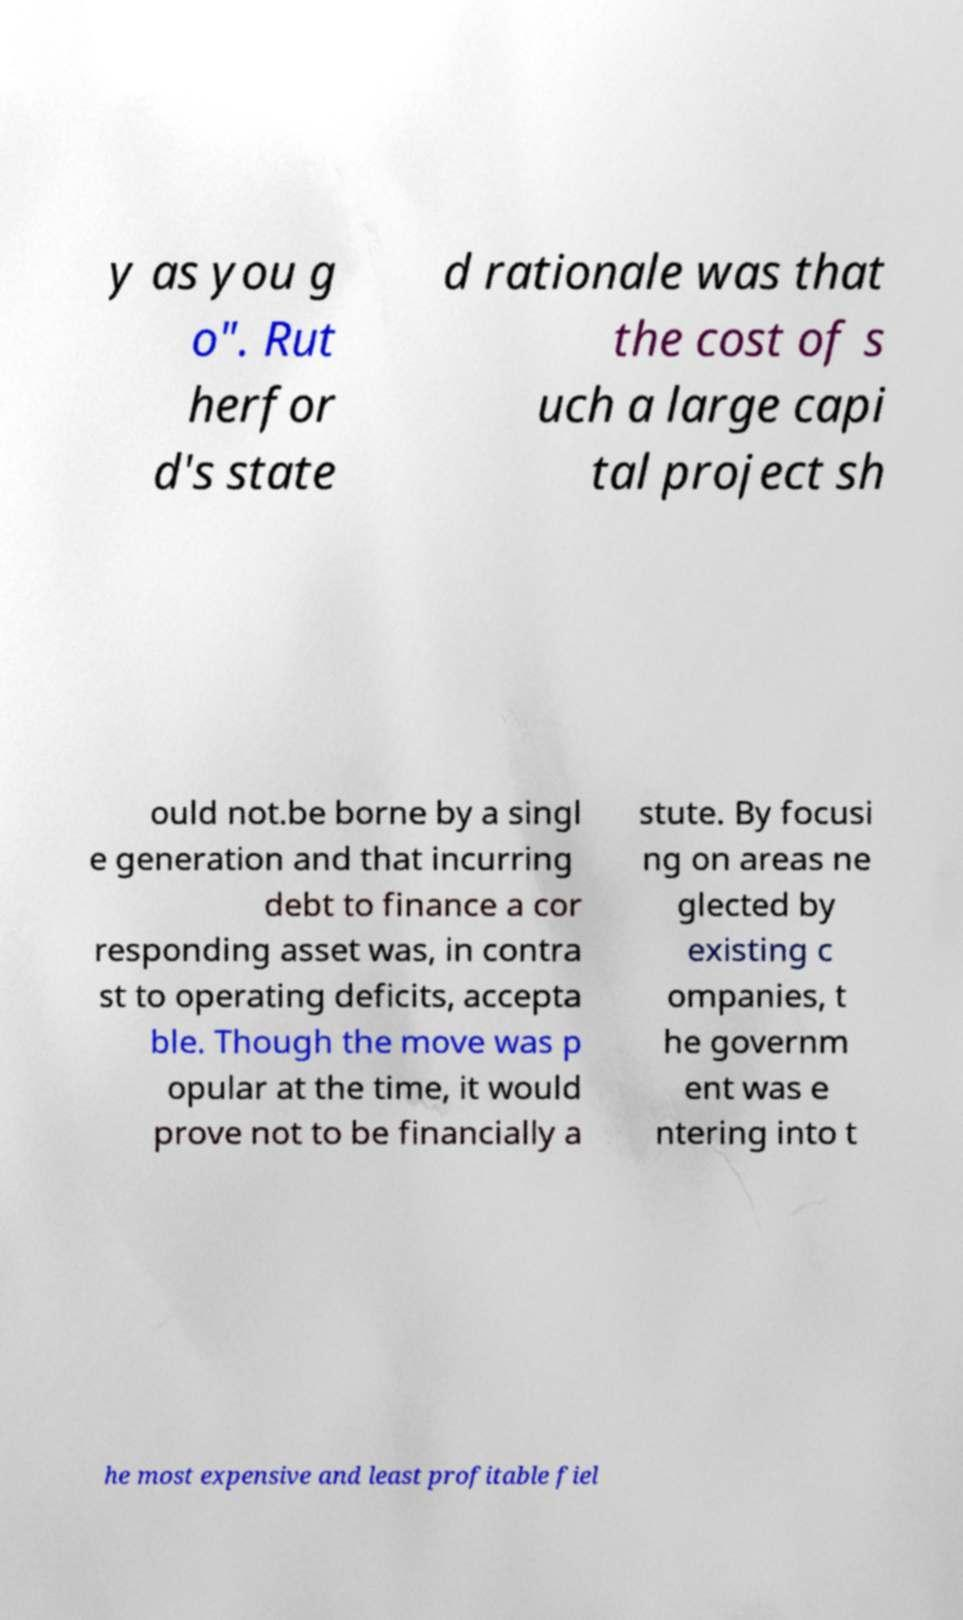For documentation purposes, I need the text within this image transcribed. Could you provide that? y as you g o". Rut herfor d's state d rationale was that the cost of s uch a large capi tal project sh ould not.be borne by a singl e generation and that incurring debt to finance a cor responding asset was, in contra st to operating deficits, accepta ble. Though the move was p opular at the time, it would prove not to be financially a stute. By focusi ng on areas ne glected by existing c ompanies, t he governm ent was e ntering into t he most expensive and least profitable fiel 